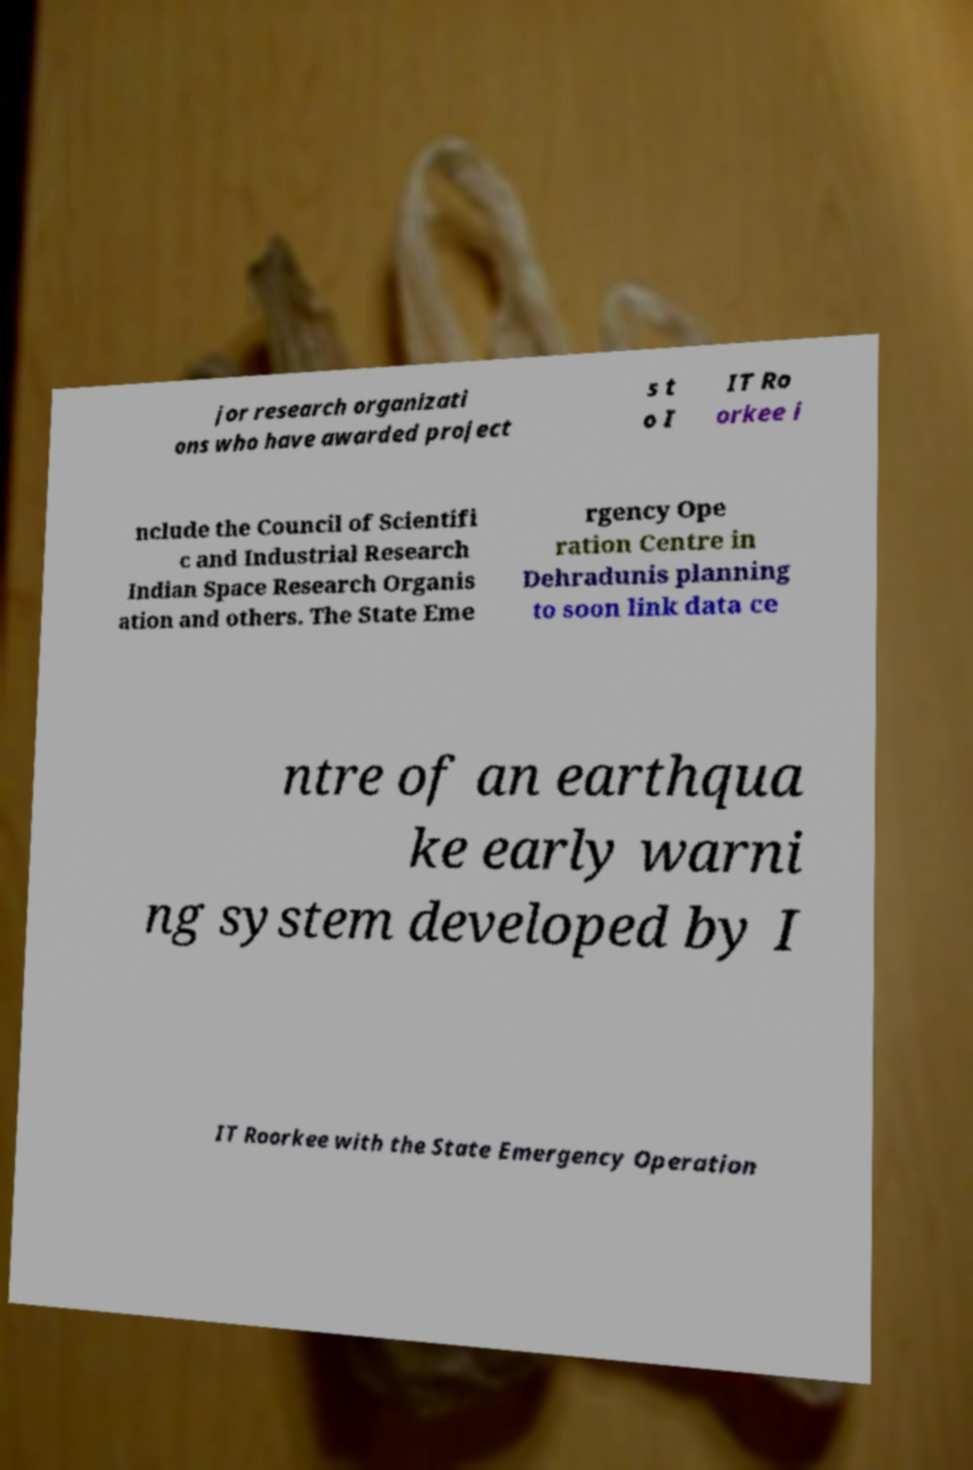Please identify and transcribe the text found in this image. jor research organizati ons who have awarded project s t o I IT Ro orkee i nclude the Council of Scientifi c and Industrial Research Indian Space Research Organis ation and others. The State Eme rgency Ope ration Centre in Dehradunis planning to soon link data ce ntre of an earthqua ke early warni ng system developed by I IT Roorkee with the State Emergency Operation 